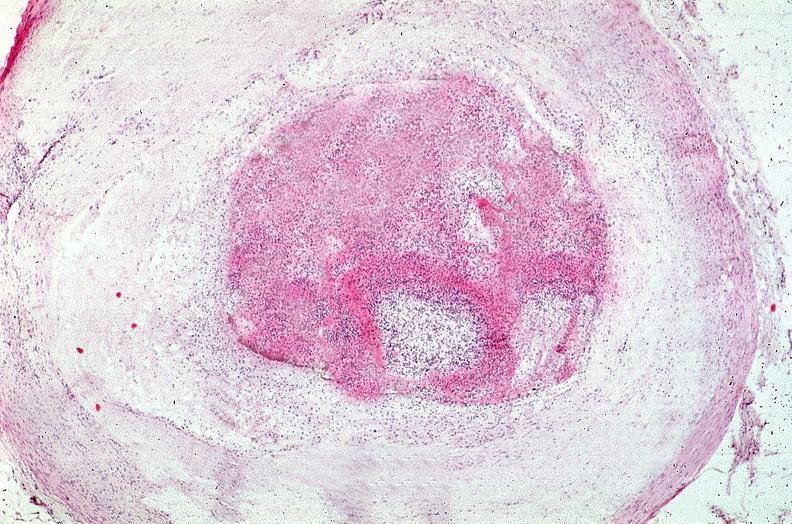s cardiovascular present?
Answer the question using a single word or phrase. Yes 